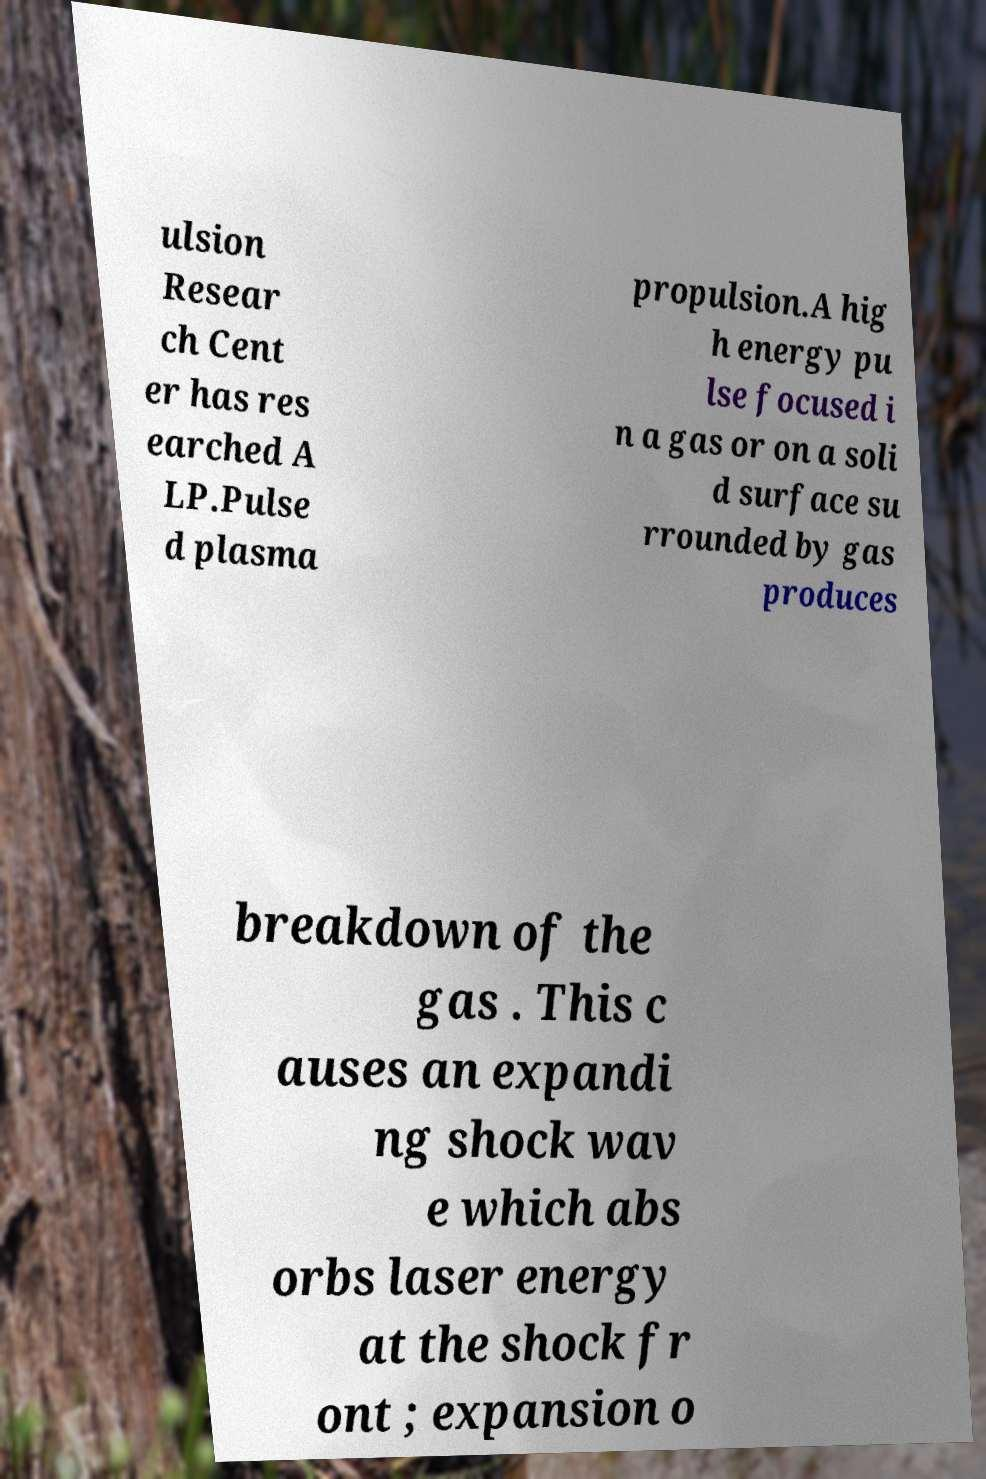Please identify and transcribe the text found in this image. ulsion Resear ch Cent er has res earched A LP.Pulse d plasma propulsion.A hig h energy pu lse focused i n a gas or on a soli d surface su rrounded by gas produces breakdown of the gas . This c auses an expandi ng shock wav e which abs orbs laser energy at the shock fr ont ; expansion o 